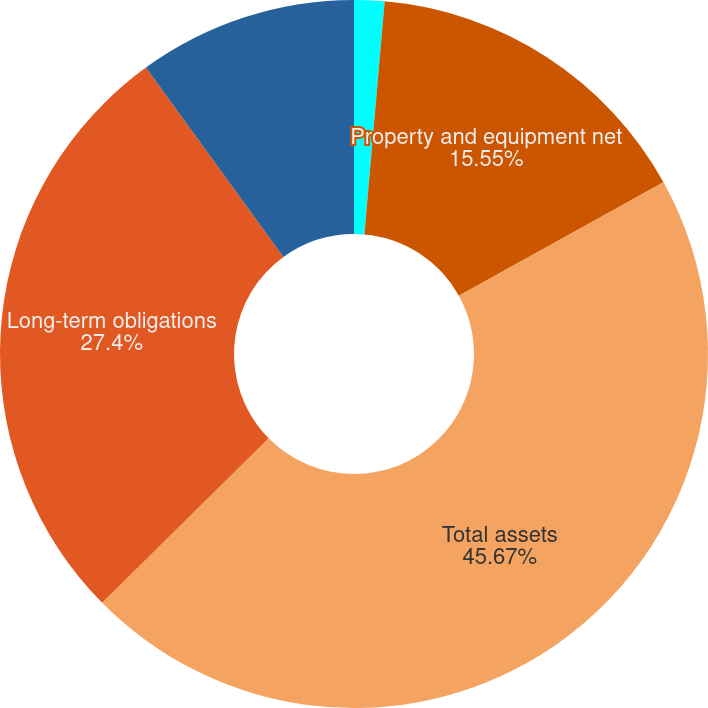<chart> <loc_0><loc_0><loc_500><loc_500><pie_chart><fcel>Cash and cash equivalents<fcel>Property and equipment net<fcel>Total assets<fcel>Long-term obligations<fcel>Total American Tower<nl><fcel>1.38%<fcel>15.55%<fcel>45.66%<fcel>27.4%<fcel>10.0%<nl></chart> 